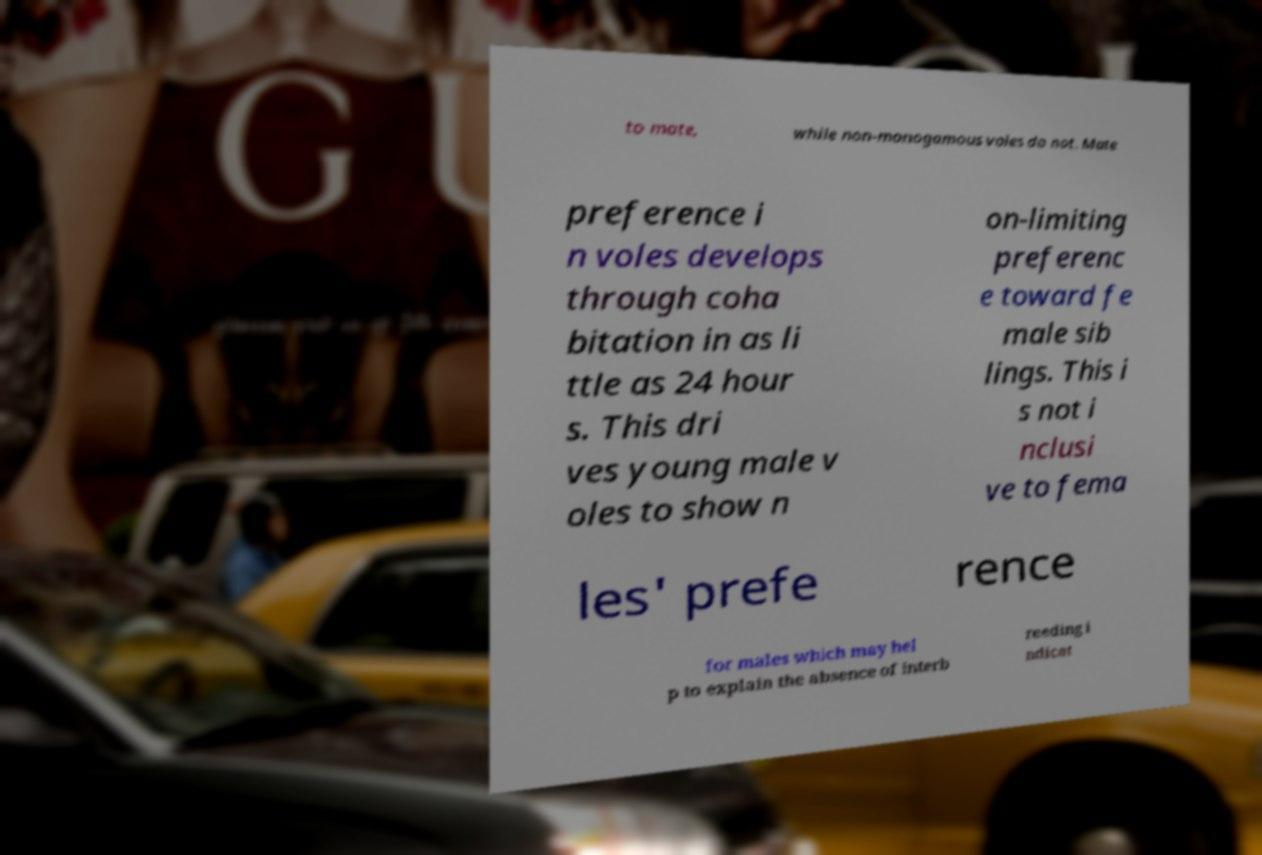There's text embedded in this image that I need extracted. Can you transcribe it verbatim? to mate, while non-monogamous voles do not. Mate preference i n voles develops through coha bitation in as li ttle as 24 hour s. This dri ves young male v oles to show n on-limiting preferenc e toward fe male sib lings. This i s not i nclusi ve to fema les' prefe rence for males which may hel p to explain the absence of interb reeding i ndicat 